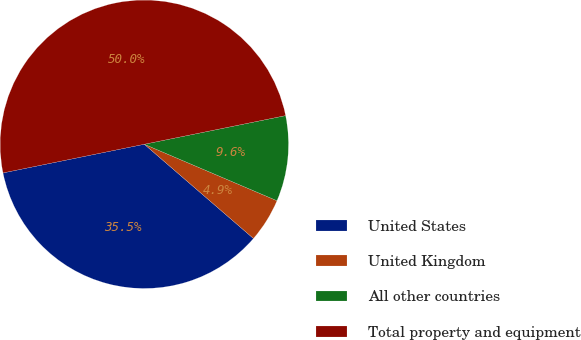Convert chart. <chart><loc_0><loc_0><loc_500><loc_500><pie_chart><fcel>United States<fcel>United Kingdom<fcel>All other countries<fcel>Total property and equipment<nl><fcel>35.48%<fcel>4.93%<fcel>9.59%<fcel>50.0%<nl></chart> 